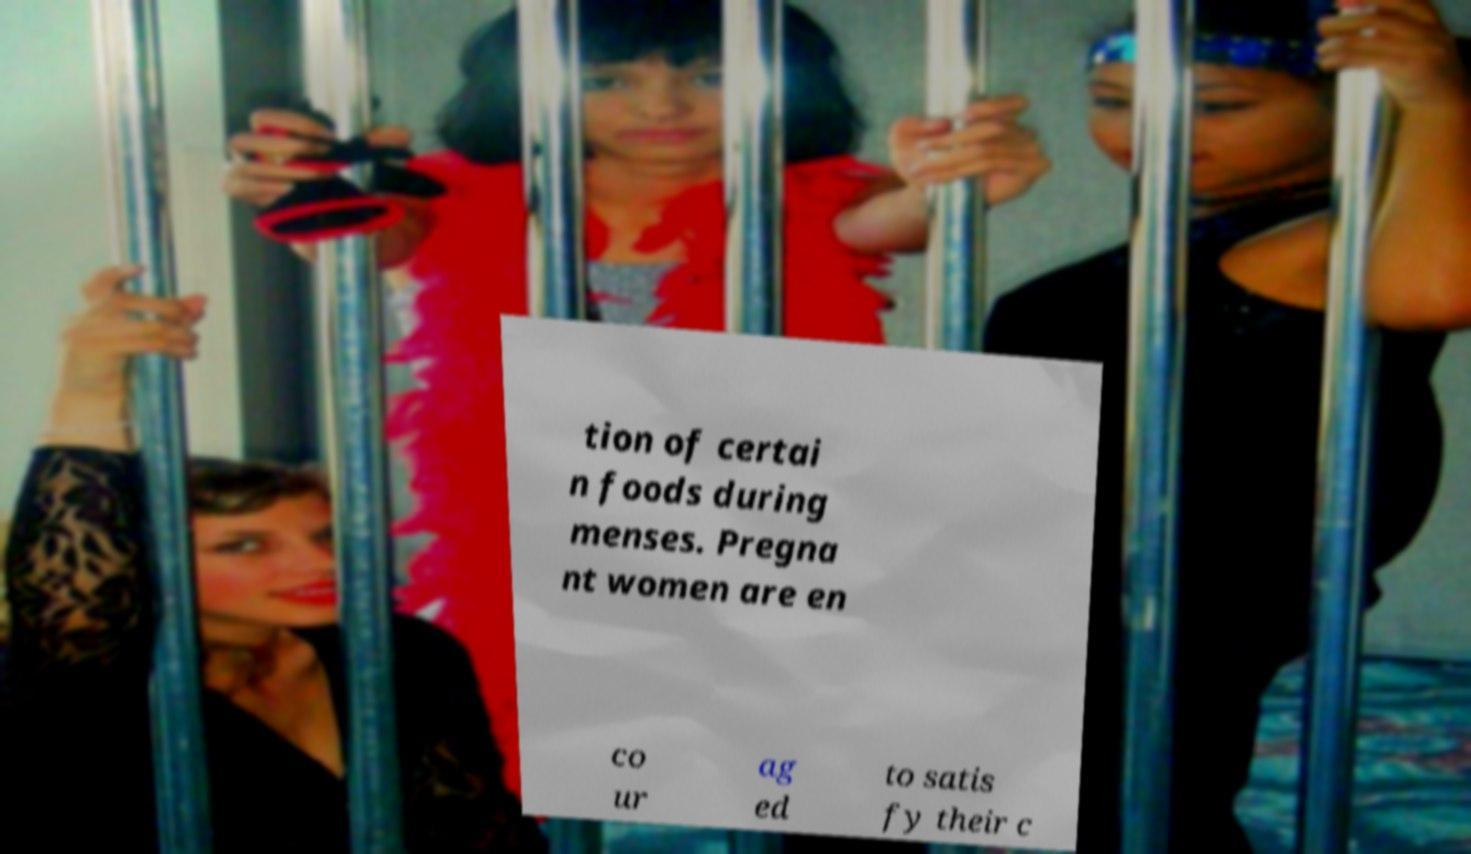There's text embedded in this image that I need extracted. Can you transcribe it verbatim? tion of certai n foods during menses. Pregna nt women are en co ur ag ed to satis fy their c 